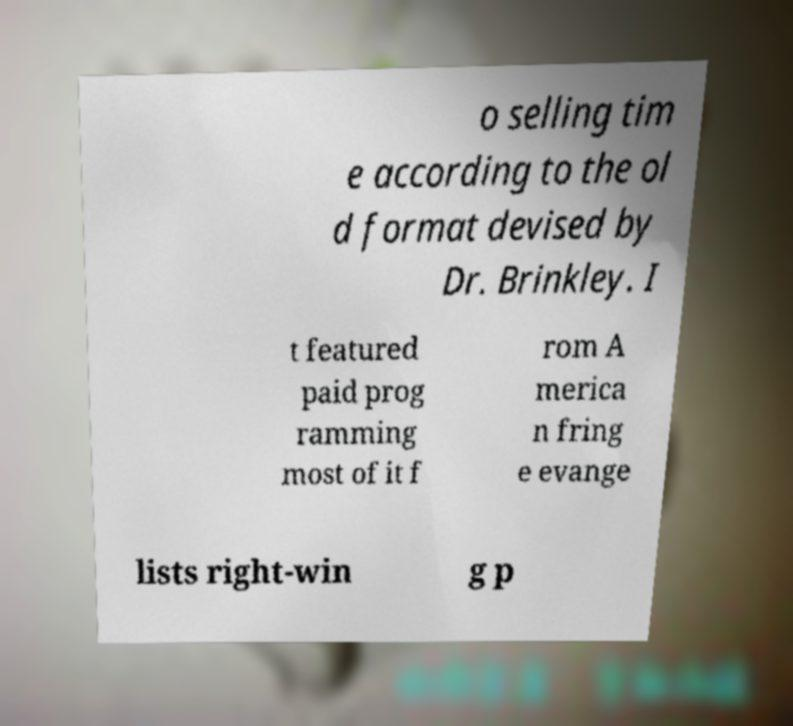Can you read and provide the text displayed in the image?This photo seems to have some interesting text. Can you extract and type it out for me? o selling tim e according to the ol d format devised by Dr. Brinkley. I t featured paid prog ramming most of it f rom A merica n fring e evange lists right-win g p 